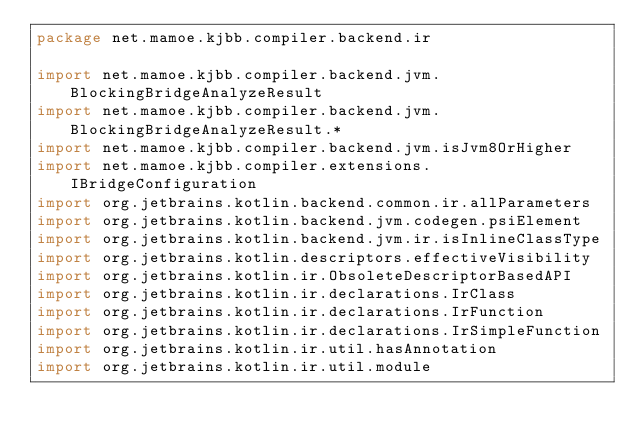<code> <loc_0><loc_0><loc_500><loc_500><_Kotlin_>package net.mamoe.kjbb.compiler.backend.ir

import net.mamoe.kjbb.compiler.backend.jvm.BlockingBridgeAnalyzeResult
import net.mamoe.kjbb.compiler.backend.jvm.BlockingBridgeAnalyzeResult.*
import net.mamoe.kjbb.compiler.backend.jvm.isJvm8OrHigher
import net.mamoe.kjbb.compiler.extensions.IBridgeConfiguration
import org.jetbrains.kotlin.backend.common.ir.allParameters
import org.jetbrains.kotlin.backend.jvm.codegen.psiElement
import org.jetbrains.kotlin.backend.jvm.ir.isInlineClassType
import org.jetbrains.kotlin.descriptors.effectiveVisibility
import org.jetbrains.kotlin.ir.ObsoleteDescriptorBasedAPI
import org.jetbrains.kotlin.ir.declarations.IrClass
import org.jetbrains.kotlin.ir.declarations.IrFunction
import org.jetbrains.kotlin.ir.declarations.IrSimpleFunction
import org.jetbrains.kotlin.ir.util.hasAnnotation
import org.jetbrains.kotlin.ir.util.module</code> 